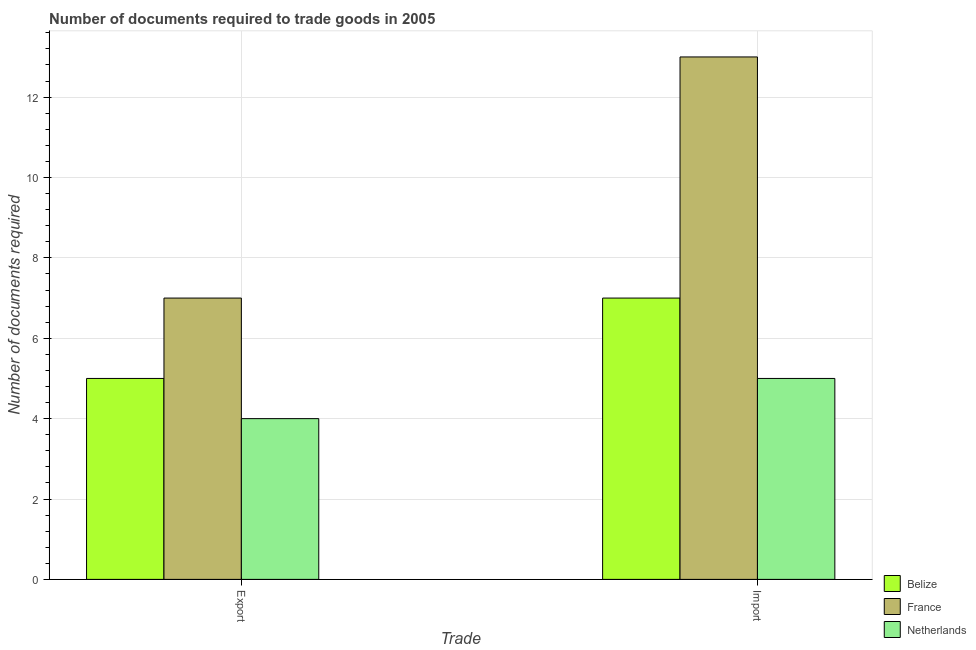How many groups of bars are there?
Your response must be concise. 2. Are the number of bars per tick equal to the number of legend labels?
Provide a short and direct response. Yes. What is the label of the 2nd group of bars from the left?
Provide a succinct answer. Import. What is the number of documents required to import goods in Belize?
Provide a short and direct response. 7. Across all countries, what is the maximum number of documents required to import goods?
Ensure brevity in your answer.  13. Across all countries, what is the minimum number of documents required to import goods?
Make the answer very short. 5. In which country was the number of documents required to export goods maximum?
Your answer should be very brief. France. In which country was the number of documents required to import goods minimum?
Your answer should be very brief. Netherlands. What is the total number of documents required to export goods in the graph?
Your answer should be very brief. 16. What is the difference between the number of documents required to import goods in Netherlands and that in France?
Provide a short and direct response. -8. What is the average number of documents required to import goods per country?
Make the answer very short. 8.33. What is the difference between the number of documents required to import goods and number of documents required to export goods in Belize?
Make the answer very short. 2. What is the ratio of the number of documents required to import goods in Belize to that in France?
Offer a very short reply. 0.54. In how many countries, is the number of documents required to import goods greater than the average number of documents required to import goods taken over all countries?
Provide a succinct answer. 1. What does the 1st bar from the right in Export represents?
Make the answer very short. Netherlands. Are all the bars in the graph horizontal?
Your answer should be very brief. No. How many countries are there in the graph?
Your answer should be very brief. 3. Does the graph contain any zero values?
Offer a terse response. No. Where does the legend appear in the graph?
Provide a succinct answer. Bottom right. How many legend labels are there?
Your answer should be compact. 3. What is the title of the graph?
Provide a short and direct response. Number of documents required to trade goods in 2005. What is the label or title of the X-axis?
Provide a short and direct response. Trade. What is the label or title of the Y-axis?
Your response must be concise. Number of documents required. What is the Number of documents required in France in Import?
Give a very brief answer. 13. Across all Trade, what is the maximum Number of documents required in Belize?
Your response must be concise. 7. Across all Trade, what is the maximum Number of documents required of France?
Keep it short and to the point. 13. Across all Trade, what is the maximum Number of documents required of Netherlands?
Your response must be concise. 5. Across all Trade, what is the minimum Number of documents required in Belize?
Give a very brief answer. 5. Across all Trade, what is the minimum Number of documents required in France?
Your answer should be very brief. 7. Across all Trade, what is the minimum Number of documents required of Netherlands?
Make the answer very short. 4. What is the total Number of documents required in Netherlands in the graph?
Your answer should be very brief. 9. What is the difference between the Number of documents required of Netherlands in Export and that in Import?
Provide a succinct answer. -1. What is the difference between the Number of documents required in France in Export and the Number of documents required in Netherlands in Import?
Provide a succinct answer. 2. What is the average Number of documents required of Belize per Trade?
Offer a terse response. 6. What is the average Number of documents required in Netherlands per Trade?
Provide a short and direct response. 4.5. What is the difference between the Number of documents required in France and Number of documents required in Netherlands in Export?
Make the answer very short. 3. What is the difference between the Number of documents required in Belize and Number of documents required in Netherlands in Import?
Your answer should be compact. 2. What is the difference between the Number of documents required in France and Number of documents required in Netherlands in Import?
Ensure brevity in your answer.  8. What is the ratio of the Number of documents required in France in Export to that in Import?
Your answer should be very brief. 0.54. What is the difference between the highest and the second highest Number of documents required in Netherlands?
Your response must be concise. 1. What is the difference between the highest and the lowest Number of documents required of Netherlands?
Make the answer very short. 1. 